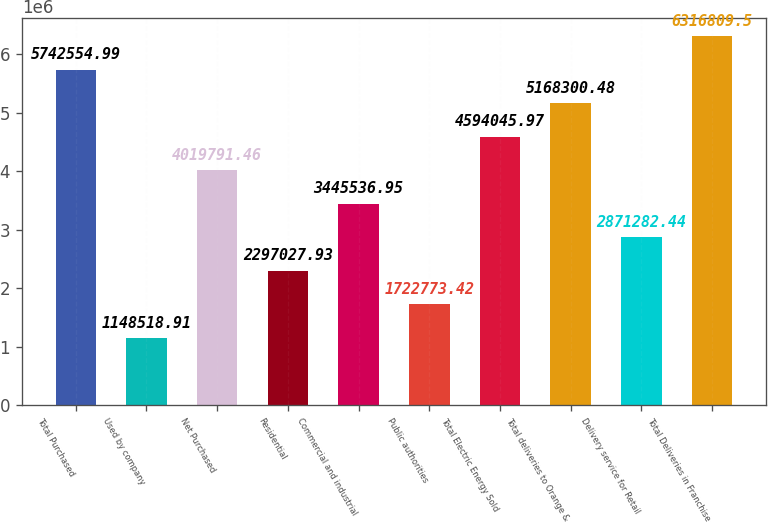Convert chart to OTSL. <chart><loc_0><loc_0><loc_500><loc_500><bar_chart><fcel>Total Purchased<fcel>Used by company<fcel>Net Purchased<fcel>Residential<fcel>Commercial and industrial<fcel>Public authorities<fcel>Total Electric Energy Sold<fcel>Total deliveries to Orange &<fcel>Delivery service for Retail<fcel>Total Deliveries in Franchise<nl><fcel>5.74255e+06<fcel>1.14852e+06<fcel>4.01979e+06<fcel>2.29703e+06<fcel>3.44554e+06<fcel>1.72277e+06<fcel>4.59405e+06<fcel>5.1683e+06<fcel>2.87128e+06<fcel>6.31681e+06<nl></chart> 